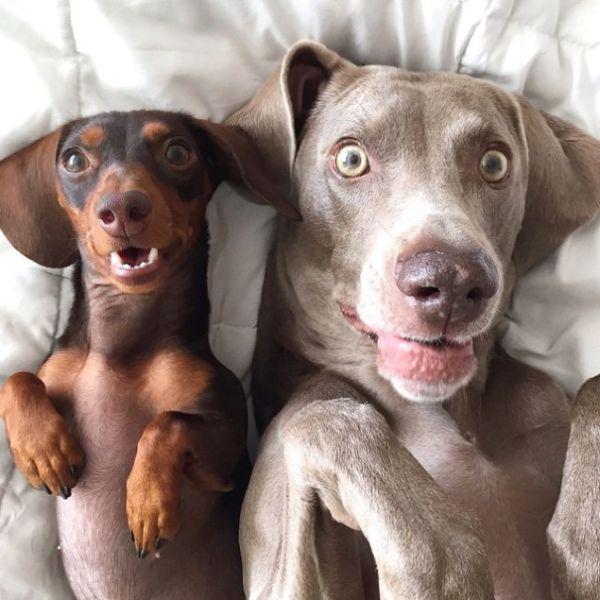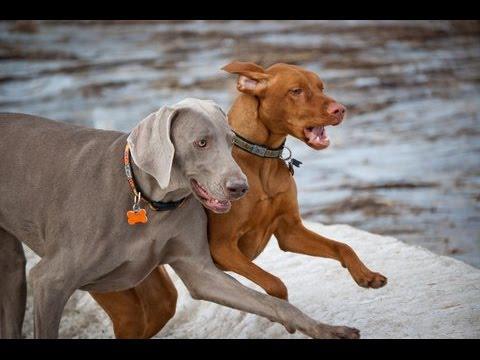The first image is the image on the left, the second image is the image on the right. For the images shown, is this caption "There are exactly two dogs in both images." true? Answer yes or no. Yes. The first image is the image on the left, the second image is the image on the right. Assess this claim about the two images: "The left image shows a brown dog and a gray dog.". Correct or not? Answer yes or no. Yes. 